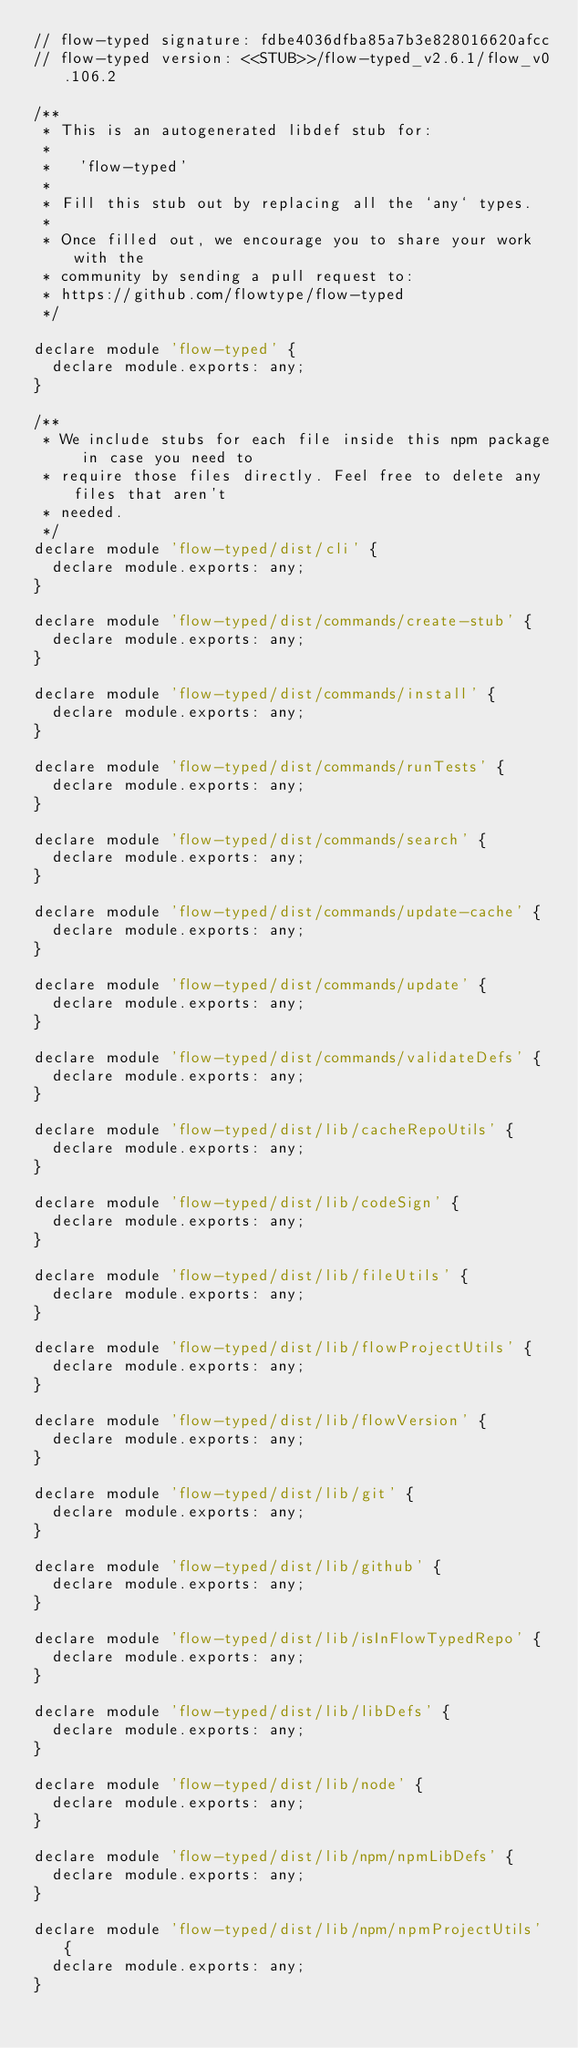Convert code to text. <code><loc_0><loc_0><loc_500><loc_500><_JavaScript_>// flow-typed signature: fdbe4036dfba85a7b3e828016620afcc
// flow-typed version: <<STUB>>/flow-typed_v2.6.1/flow_v0.106.2

/**
 * This is an autogenerated libdef stub for:
 *
 *   'flow-typed'
 *
 * Fill this stub out by replacing all the `any` types.
 *
 * Once filled out, we encourage you to share your work with the
 * community by sending a pull request to:
 * https://github.com/flowtype/flow-typed
 */

declare module 'flow-typed' {
  declare module.exports: any;
}

/**
 * We include stubs for each file inside this npm package in case you need to
 * require those files directly. Feel free to delete any files that aren't
 * needed.
 */
declare module 'flow-typed/dist/cli' {
  declare module.exports: any;
}

declare module 'flow-typed/dist/commands/create-stub' {
  declare module.exports: any;
}

declare module 'flow-typed/dist/commands/install' {
  declare module.exports: any;
}

declare module 'flow-typed/dist/commands/runTests' {
  declare module.exports: any;
}

declare module 'flow-typed/dist/commands/search' {
  declare module.exports: any;
}

declare module 'flow-typed/dist/commands/update-cache' {
  declare module.exports: any;
}

declare module 'flow-typed/dist/commands/update' {
  declare module.exports: any;
}

declare module 'flow-typed/dist/commands/validateDefs' {
  declare module.exports: any;
}

declare module 'flow-typed/dist/lib/cacheRepoUtils' {
  declare module.exports: any;
}

declare module 'flow-typed/dist/lib/codeSign' {
  declare module.exports: any;
}

declare module 'flow-typed/dist/lib/fileUtils' {
  declare module.exports: any;
}

declare module 'flow-typed/dist/lib/flowProjectUtils' {
  declare module.exports: any;
}

declare module 'flow-typed/dist/lib/flowVersion' {
  declare module.exports: any;
}

declare module 'flow-typed/dist/lib/git' {
  declare module.exports: any;
}

declare module 'flow-typed/dist/lib/github' {
  declare module.exports: any;
}

declare module 'flow-typed/dist/lib/isInFlowTypedRepo' {
  declare module.exports: any;
}

declare module 'flow-typed/dist/lib/libDefs' {
  declare module.exports: any;
}

declare module 'flow-typed/dist/lib/node' {
  declare module.exports: any;
}

declare module 'flow-typed/dist/lib/npm/npmLibDefs' {
  declare module.exports: any;
}

declare module 'flow-typed/dist/lib/npm/npmProjectUtils' {
  declare module.exports: any;
}
</code> 